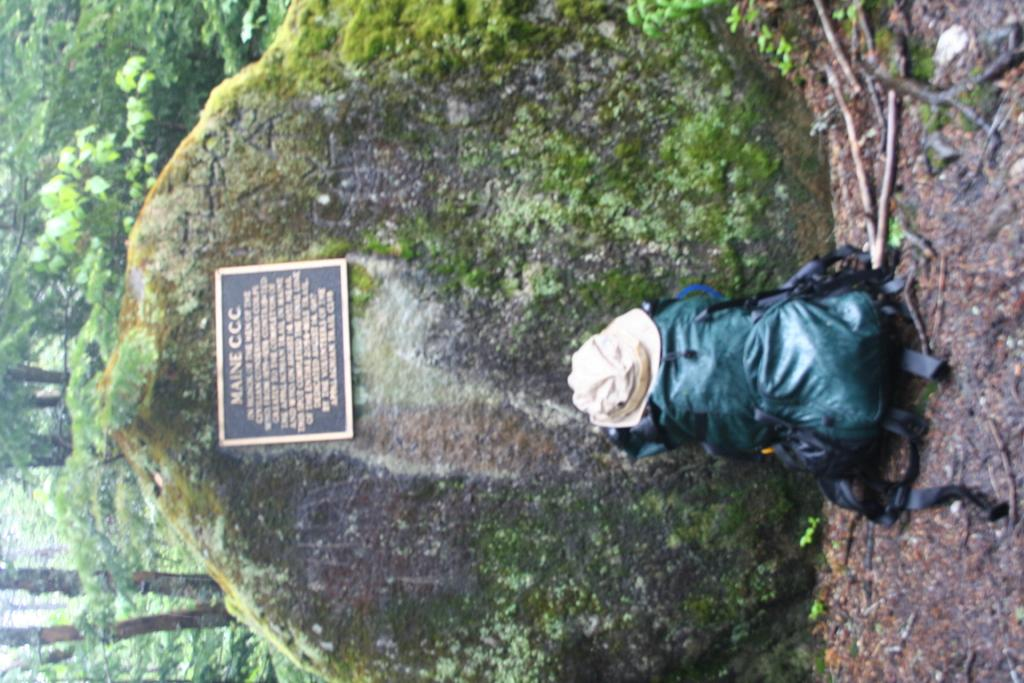What object is located on the right side of the image? There is a backpack on the right side of the image. What accessory is also present on the right side of the image? There is a hat on the right side of the image. What type of natural elements can be seen on the left side of the image? There are trees on the left side of the image. What other objects are present on the left side of the image? There is a rock and a board on the left side of the image. What is the tendency of the stem in the image? There is no stem present in the image. What type of material is the leather used for in the image? There is no leather present in the image. 